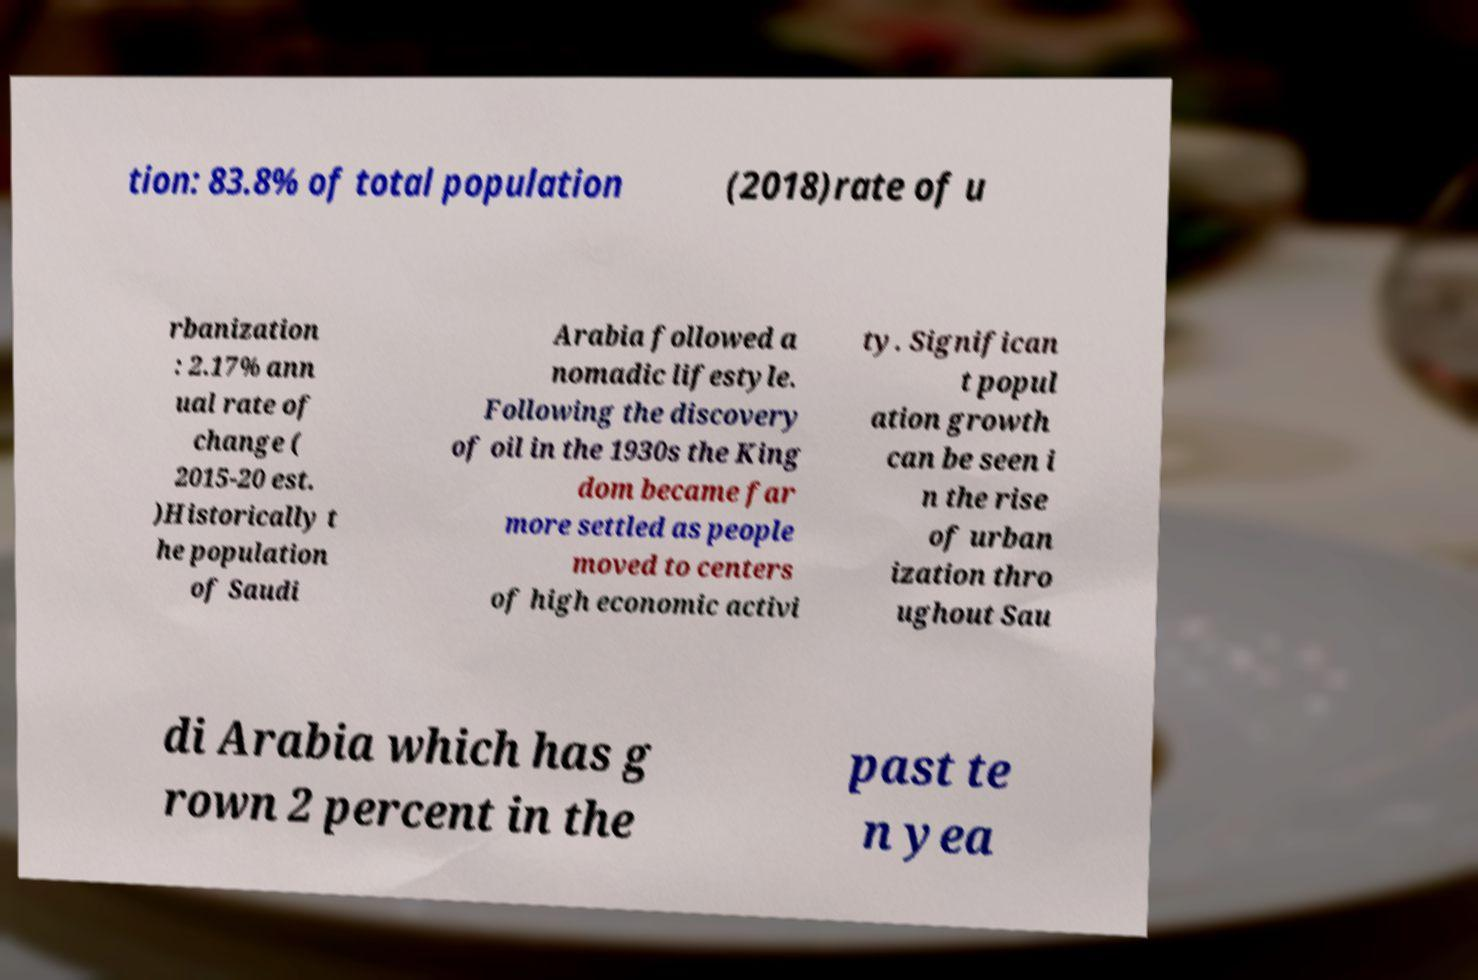What messages or text are displayed in this image? I need them in a readable, typed format. tion: 83.8% of total population (2018)rate of u rbanization : 2.17% ann ual rate of change ( 2015-20 est. )Historically t he population of Saudi Arabia followed a nomadic lifestyle. Following the discovery of oil in the 1930s the King dom became far more settled as people moved to centers of high economic activi ty. Significan t popul ation growth can be seen i n the rise of urban ization thro ughout Sau di Arabia which has g rown 2 percent in the past te n yea 